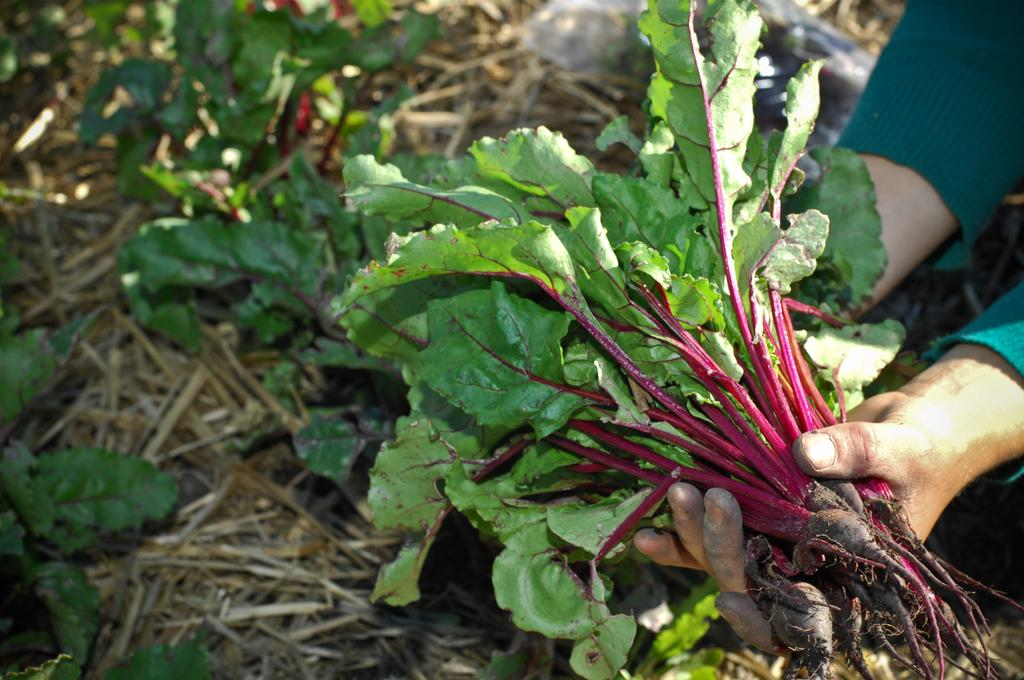What is the person holding in the image? There is a person's hand holding beetroots in the image. What can be seen in the background of the image? There is grass in the background of the image. Are there any plant-related elements visible in the image? Yes, there are leaves visible in the image. What type of silverware is being used to hold the beetroots in the image? There is no silverware visible in the image; the person's hand is holding the beetroots. What toys can be seen in the image? There are no toys present in the image. 